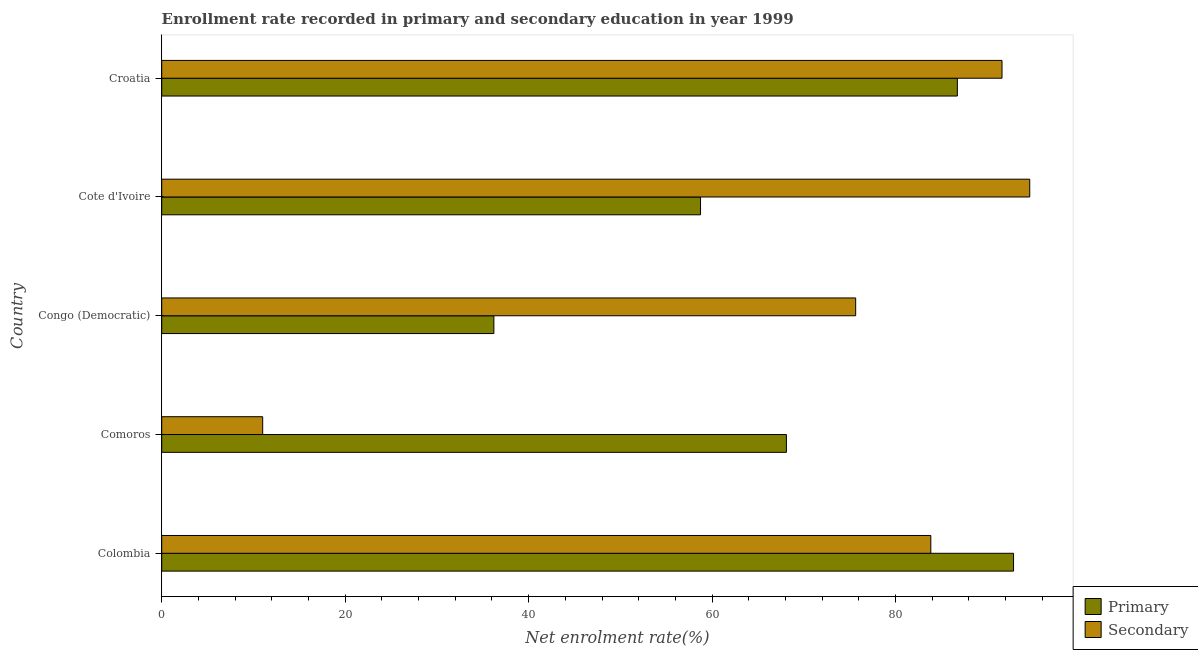How many groups of bars are there?
Keep it short and to the point. 5. Are the number of bars per tick equal to the number of legend labels?
Keep it short and to the point. Yes. How many bars are there on the 2nd tick from the bottom?
Provide a short and direct response. 2. What is the label of the 3rd group of bars from the top?
Offer a very short reply. Congo (Democratic). In how many cases, is the number of bars for a given country not equal to the number of legend labels?
Offer a terse response. 0. What is the enrollment rate in secondary education in Congo (Democratic)?
Make the answer very short. 75.65. Across all countries, what is the maximum enrollment rate in secondary education?
Provide a succinct answer. 94.63. Across all countries, what is the minimum enrollment rate in secondary education?
Provide a succinct answer. 11.01. In which country was the enrollment rate in primary education maximum?
Your answer should be compact. Colombia. In which country was the enrollment rate in secondary education minimum?
Make the answer very short. Comoros. What is the total enrollment rate in secondary education in the graph?
Provide a short and direct response. 356.73. What is the difference between the enrollment rate in secondary education in Cote d'Ivoire and that in Croatia?
Ensure brevity in your answer.  3.02. What is the difference between the enrollment rate in secondary education in Congo (Democratic) and the enrollment rate in primary education in Cote d'Ivoire?
Offer a very short reply. 16.91. What is the average enrollment rate in secondary education per country?
Keep it short and to the point. 71.35. What is the difference between the enrollment rate in secondary education and enrollment rate in primary education in Comoros?
Your answer should be very brief. -57.09. What is the ratio of the enrollment rate in primary education in Colombia to that in Congo (Democratic)?
Make the answer very short. 2.56. Is the enrollment rate in secondary education in Congo (Democratic) less than that in Croatia?
Your answer should be compact. Yes. What is the difference between the highest and the second highest enrollment rate in secondary education?
Your answer should be compact. 3.02. What is the difference between the highest and the lowest enrollment rate in secondary education?
Provide a short and direct response. 83.62. In how many countries, is the enrollment rate in primary education greater than the average enrollment rate in primary education taken over all countries?
Ensure brevity in your answer.  2. What does the 2nd bar from the top in Cote d'Ivoire represents?
Provide a short and direct response. Primary. What does the 1st bar from the bottom in Cote d'Ivoire represents?
Offer a terse response. Primary. Are all the bars in the graph horizontal?
Offer a terse response. Yes. How many countries are there in the graph?
Keep it short and to the point. 5. Are the values on the major ticks of X-axis written in scientific E-notation?
Keep it short and to the point. No. How are the legend labels stacked?
Give a very brief answer. Vertical. What is the title of the graph?
Give a very brief answer. Enrollment rate recorded in primary and secondary education in year 1999. What is the label or title of the X-axis?
Ensure brevity in your answer.  Net enrolment rate(%). What is the label or title of the Y-axis?
Keep it short and to the point. Country. What is the Net enrolment rate(%) in Primary in Colombia?
Keep it short and to the point. 92.86. What is the Net enrolment rate(%) in Secondary in Colombia?
Offer a very short reply. 83.84. What is the Net enrolment rate(%) in Primary in Comoros?
Your response must be concise. 68.1. What is the Net enrolment rate(%) in Secondary in Comoros?
Offer a very short reply. 11.01. What is the Net enrolment rate(%) of Primary in Congo (Democratic)?
Ensure brevity in your answer.  36.21. What is the Net enrolment rate(%) in Secondary in Congo (Democratic)?
Offer a very short reply. 75.65. What is the Net enrolment rate(%) in Primary in Cote d'Ivoire?
Keep it short and to the point. 58.74. What is the Net enrolment rate(%) of Secondary in Cote d'Ivoire?
Offer a very short reply. 94.63. What is the Net enrolment rate(%) in Primary in Croatia?
Offer a terse response. 86.74. What is the Net enrolment rate(%) in Secondary in Croatia?
Your response must be concise. 91.6. Across all countries, what is the maximum Net enrolment rate(%) of Primary?
Your response must be concise. 92.86. Across all countries, what is the maximum Net enrolment rate(%) of Secondary?
Offer a very short reply. 94.63. Across all countries, what is the minimum Net enrolment rate(%) of Primary?
Provide a short and direct response. 36.21. Across all countries, what is the minimum Net enrolment rate(%) of Secondary?
Your answer should be very brief. 11.01. What is the total Net enrolment rate(%) of Primary in the graph?
Your answer should be very brief. 342.65. What is the total Net enrolment rate(%) in Secondary in the graph?
Ensure brevity in your answer.  356.73. What is the difference between the Net enrolment rate(%) of Primary in Colombia and that in Comoros?
Your answer should be compact. 24.76. What is the difference between the Net enrolment rate(%) of Secondary in Colombia and that in Comoros?
Provide a short and direct response. 72.83. What is the difference between the Net enrolment rate(%) in Primary in Colombia and that in Congo (Democratic)?
Your answer should be very brief. 56.65. What is the difference between the Net enrolment rate(%) of Secondary in Colombia and that in Congo (Democratic)?
Make the answer very short. 8.19. What is the difference between the Net enrolment rate(%) in Primary in Colombia and that in Cote d'Ivoire?
Your answer should be very brief. 34.12. What is the difference between the Net enrolment rate(%) of Secondary in Colombia and that in Cote d'Ivoire?
Ensure brevity in your answer.  -10.78. What is the difference between the Net enrolment rate(%) of Primary in Colombia and that in Croatia?
Your answer should be compact. 6.13. What is the difference between the Net enrolment rate(%) in Secondary in Colombia and that in Croatia?
Give a very brief answer. -7.76. What is the difference between the Net enrolment rate(%) of Primary in Comoros and that in Congo (Democratic)?
Give a very brief answer. 31.89. What is the difference between the Net enrolment rate(%) in Secondary in Comoros and that in Congo (Democratic)?
Make the answer very short. -64.64. What is the difference between the Net enrolment rate(%) in Primary in Comoros and that in Cote d'Ivoire?
Keep it short and to the point. 9.36. What is the difference between the Net enrolment rate(%) in Secondary in Comoros and that in Cote d'Ivoire?
Your answer should be compact. -83.62. What is the difference between the Net enrolment rate(%) in Primary in Comoros and that in Croatia?
Offer a terse response. -18.64. What is the difference between the Net enrolment rate(%) of Secondary in Comoros and that in Croatia?
Ensure brevity in your answer.  -80.6. What is the difference between the Net enrolment rate(%) of Primary in Congo (Democratic) and that in Cote d'Ivoire?
Provide a succinct answer. -22.53. What is the difference between the Net enrolment rate(%) in Secondary in Congo (Democratic) and that in Cote d'Ivoire?
Ensure brevity in your answer.  -18.98. What is the difference between the Net enrolment rate(%) in Primary in Congo (Democratic) and that in Croatia?
Provide a short and direct response. -50.53. What is the difference between the Net enrolment rate(%) in Secondary in Congo (Democratic) and that in Croatia?
Make the answer very short. -15.95. What is the difference between the Net enrolment rate(%) of Primary in Cote d'Ivoire and that in Croatia?
Offer a terse response. -28. What is the difference between the Net enrolment rate(%) in Secondary in Cote d'Ivoire and that in Croatia?
Offer a terse response. 3.02. What is the difference between the Net enrolment rate(%) of Primary in Colombia and the Net enrolment rate(%) of Secondary in Comoros?
Offer a terse response. 81.86. What is the difference between the Net enrolment rate(%) of Primary in Colombia and the Net enrolment rate(%) of Secondary in Congo (Democratic)?
Provide a succinct answer. 17.21. What is the difference between the Net enrolment rate(%) in Primary in Colombia and the Net enrolment rate(%) in Secondary in Cote d'Ivoire?
Provide a succinct answer. -1.76. What is the difference between the Net enrolment rate(%) in Primary in Colombia and the Net enrolment rate(%) in Secondary in Croatia?
Ensure brevity in your answer.  1.26. What is the difference between the Net enrolment rate(%) of Primary in Comoros and the Net enrolment rate(%) of Secondary in Congo (Democratic)?
Make the answer very short. -7.55. What is the difference between the Net enrolment rate(%) in Primary in Comoros and the Net enrolment rate(%) in Secondary in Cote d'Ivoire?
Make the answer very short. -26.53. What is the difference between the Net enrolment rate(%) in Primary in Comoros and the Net enrolment rate(%) in Secondary in Croatia?
Provide a succinct answer. -23.5. What is the difference between the Net enrolment rate(%) of Primary in Congo (Democratic) and the Net enrolment rate(%) of Secondary in Cote d'Ivoire?
Make the answer very short. -58.42. What is the difference between the Net enrolment rate(%) in Primary in Congo (Democratic) and the Net enrolment rate(%) in Secondary in Croatia?
Offer a terse response. -55.39. What is the difference between the Net enrolment rate(%) in Primary in Cote d'Ivoire and the Net enrolment rate(%) in Secondary in Croatia?
Give a very brief answer. -32.87. What is the average Net enrolment rate(%) in Primary per country?
Make the answer very short. 68.53. What is the average Net enrolment rate(%) of Secondary per country?
Offer a very short reply. 71.35. What is the difference between the Net enrolment rate(%) of Primary and Net enrolment rate(%) of Secondary in Colombia?
Offer a terse response. 9.02. What is the difference between the Net enrolment rate(%) of Primary and Net enrolment rate(%) of Secondary in Comoros?
Offer a very short reply. 57.09. What is the difference between the Net enrolment rate(%) in Primary and Net enrolment rate(%) in Secondary in Congo (Democratic)?
Offer a terse response. -39.44. What is the difference between the Net enrolment rate(%) of Primary and Net enrolment rate(%) of Secondary in Cote d'Ivoire?
Offer a very short reply. -35.89. What is the difference between the Net enrolment rate(%) in Primary and Net enrolment rate(%) in Secondary in Croatia?
Offer a terse response. -4.87. What is the ratio of the Net enrolment rate(%) of Primary in Colombia to that in Comoros?
Ensure brevity in your answer.  1.36. What is the ratio of the Net enrolment rate(%) in Secondary in Colombia to that in Comoros?
Your answer should be compact. 7.62. What is the ratio of the Net enrolment rate(%) in Primary in Colombia to that in Congo (Democratic)?
Your answer should be very brief. 2.56. What is the ratio of the Net enrolment rate(%) of Secondary in Colombia to that in Congo (Democratic)?
Provide a succinct answer. 1.11. What is the ratio of the Net enrolment rate(%) of Primary in Colombia to that in Cote d'Ivoire?
Ensure brevity in your answer.  1.58. What is the ratio of the Net enrolment rate(%) of Secondary in Colombia to that in Cote d'Ivoire?
Provide a succinct answer. 0.89. What is the ratio of the Net enrolment rate(%) in Primary in Colombia to that in Croatia?
Keep it short and to the point. 1.07. What is the ratio of the Net enrolment rate(%) of Secondary in Colombia to that in Croatia?
Offer a very short reply. 0.92. What is the ratio of the Net enrolment rate(%) in Primary in Comoros to that in Congo (Democratic)?
Ensure brevity in your answer.  1.88. What is the ratio of the Net enrolment rate(%) of Secondary in Comoros to that in Congo (Democratic)?
Make the answer very short. 0.15. What is the ratio of the Net enrolment rate(%) of Primary in Comoros to that in Cote d'Ivoire?
Make the answer very short. 1.16. What is the ratio of the Net enrolment rate(%) in Secondary in Comoros to that in Cote d'Ivoire?
Your answer should be compact. 0.12. What is the ratio of the Net enrolment rate(%) of Primary in Comoros to that in Croatia?
Make the answer very short. 0.79. What is the ratio of the Net enrolment rate(%) in Secondary in Comoros to that in Croatia?
Provide a succinct answer. 0.12. What is the ratio of the Net enrolment rate(%) of Primary in Congo (Democratic) to that in Cote d'Ivoire?
Provide a succinct answer. 0.62. What is the ratio of the Net enrolment rate(%) in Secondary in Congo (Democratic) to that in Cote d'Ivoire?
Give a very brief answer. 0.8. What is the ratio of the Net enrolment rate(%) of Primary in Congo (Democratic) to that in Croatia?
Your answer should be compact. 0.42. What is the ratio of the Net enrolment rate(%) in Secondary in Congo (Democratic) to that in Croatia?
Your response must be concise. 0.83. What is the ratio of the Net enrolment rate(%) in Primary in Cote d'Ivoire to that in Croatia?
Ensure brevity in your answer.  0.68. What is the ratio of the Net enrolment rate(%) in Secondary in Cote d'Ivoire to that in Croatia?
Make the answer very short. 1.03. What is the difference between the highest and the second highest Net enrolment rate(%) of Primary?
Offer a very short reply. 6.13. What is the difference between the highest and the second highest Net enrolment rate(%) in Secondary?
Your response must be concise. 3.02. What is the difference between the highest and the lowest Net enrolment rate(%) of Primary?
Offer a very short reply. 56.65. What is the difference between the highest and the lowest Net enrolment rate(%) of Secondary?
Keep it short and to the point. 83.62. 